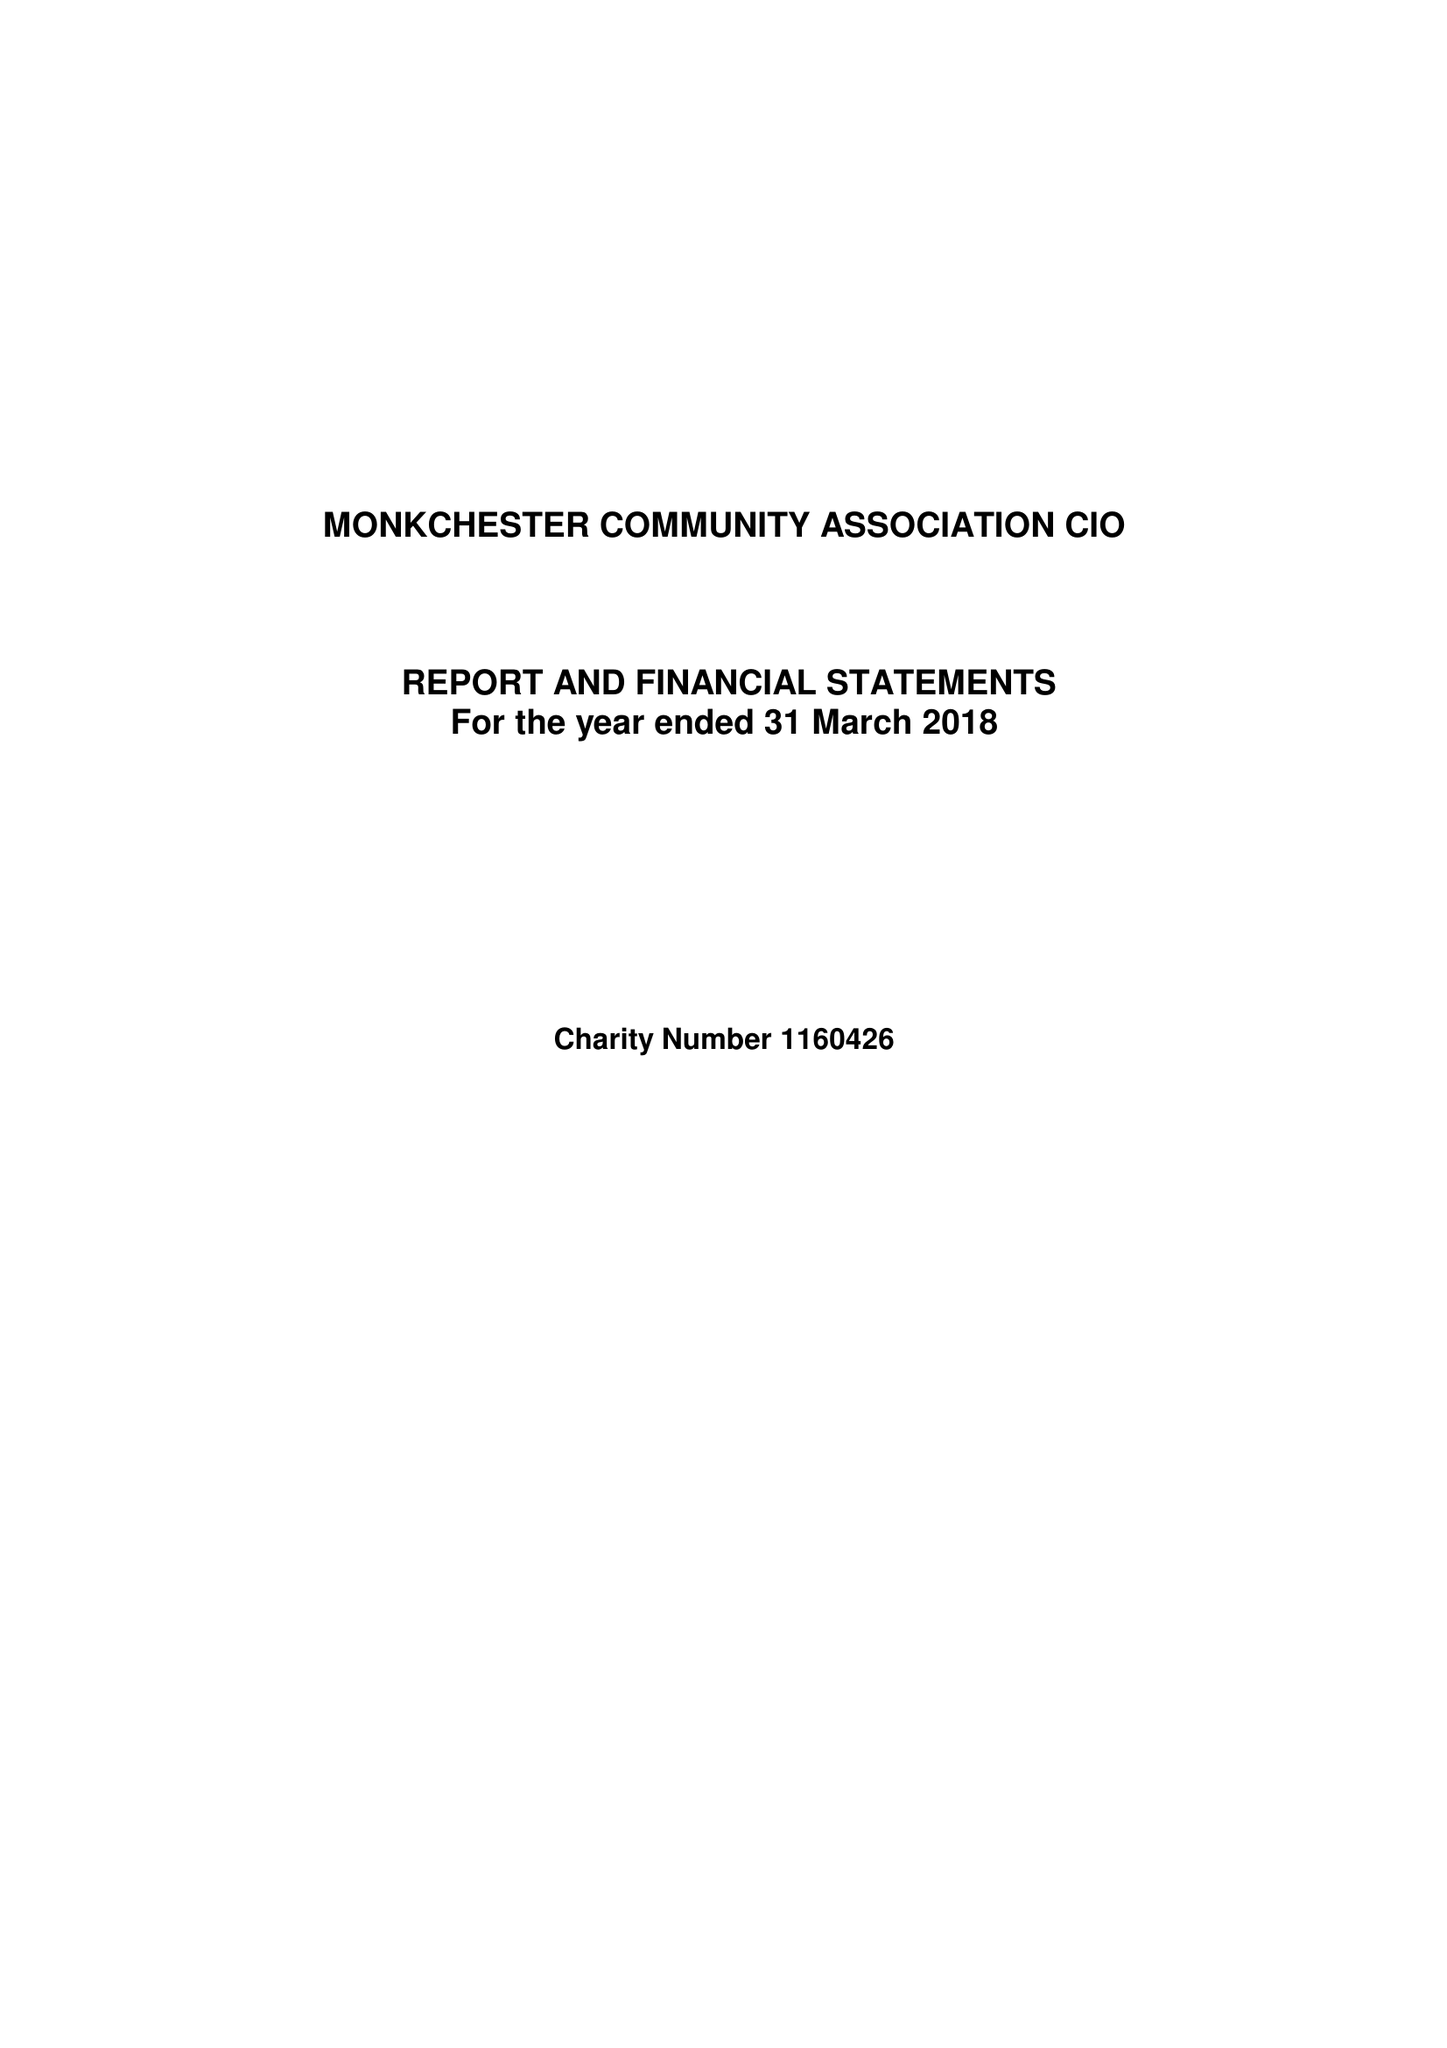What is the value for the address__street_line?
Answer the question using a single word or phrase. 204 MONKCHESTER ROAD 